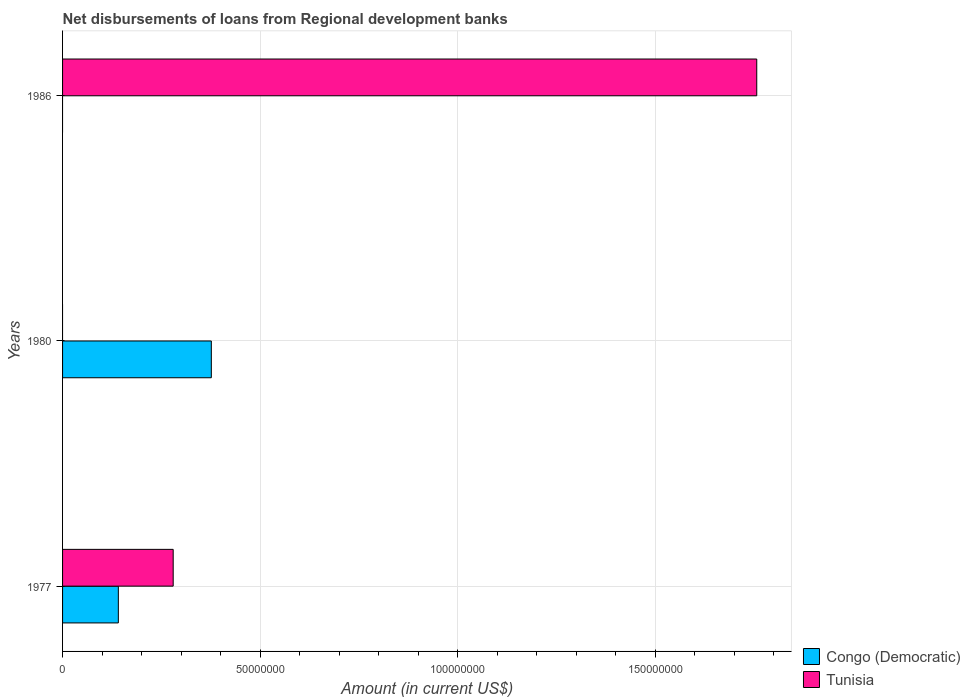How many different coloured bars are there?
Your response must be concise. 2. How many bars are there on the 2nd tick from the top?
Ensure brevity in your answer.  1. What is the label of the 3rd group of bars from the top?
Give a very brief answer. 1977. What is the amount of disbursements of loans from regional development banks in Tunisia in 1977?
Offer a terse response. 2.80e+07. Across all years, what is the maximum amount of disbursements of loans from regional development banks in Congo (Democratic)?
Offer a very short reply. 3.77e+07. In which year was the amount of disbursements of loans from regional development banks in Tunisia maximum?
Keep it short and to the point. 1986. What is the total amount of disbursements of loans from regional development banks in Congo (Democratic) in the graph?
Provide a succinct answer. 5.18e+07. What is the difference between the amount of disbursements of loans from regional development banks in Congo (Democratic) in 1977 and that in 1980?
Provide a succinct answer. -2.35e+07. What is the difference between the amount of disbursements of loans from regional development banks in Tunisia in 1977 and the amount of disbursements of loans from regional development banks in Congo (Democratic) in 1986?
Give a very brief answer. 2.80e+07. What is the average amount of disbursements of loans from regional development banks in Congo (Democratic) per year?
Provide a short and direct response. 1.73e+07. In the year 1977, what is the difference between the amount of disbursements of loans from regional development banks in Congo (Democratic) and amount of disbursements of loans from regional development banks in Tunisia?
Give a very brief answer. -1.39e+07. What is the ratio of the amount of disbursements of loans from regional development banks in Congo (Democratic) in 1977 to that in 1980?
Your response must be concise. 0.37. What is the difference between the highest and the lowest amount of disbursements of loans from regional development banks in Congo (Democratic)?
Keep it short and to the point. 3.77e+07. Is the sum of the amount of disbursements of loans from regional development banks in Congo (Democratic) in 1977 and 1980 greater than the maximum amount of disbursements of loans from regional development banks in Tunisia across all years?
Offer a very short reply. No. How many years are there in the graph?
Make the answer very short. 3. What is the difference between two consecutive major ticks on the X-axis?
Your answer should be compact. 5.00e+07. Does the graph contain any zero values?
Your answer should be compact. Yes. Does the graph contain grids?
Ensure brevity in your answer.  Yes. Where does the legend appear in the graph?
Ensure brevity in your answer.  Bottom right. How many legend labels are there?
Your response must be concise. 2. How are the legend labels stacked?
Your answer should be very brief. Vertical. What is the title of the graph?
Your answer should be very brief. Net disbursements of loans from Regional development banks. Does "Israel" appear as one of the legend labels in the graph?
Give a very brief answer. No. What is the label or title of the Y-axis?
Your answer should be very brief. Years. What is the Amount (in current US$) in Congo (Democratic) in 1977?
Offer a very short reply. 1.41e+07. What is the Amount (in current US$) in Tunisia in 1977?
Your answer should be very brief. 2.80e+07. What is the Amount (in current US$) in Congo (Democratic) in 1980?
Make the answer very short. 3.77e+07. What is the Amount (in current US$) in Congo (Democratic) in 1986?
Offer a terse response. 0. What is the Amount (in current US$) of Tunisia in 1986?
Give a very brief answer. 1.76e+08. Across all years, what is the maximum Amount (in current US$) of Congo (Democratic)?
Ensure brevity in your answer.  3.77e+07. Across all years, what is the maximum Amount (in current US$) in Tunisia?
Give a very brief answer. 1.76e+08. Across all years, what is the minimum Amount (in current US$) of Congo (Democratic)?
Give a very brief answer. 0. Across all years, what is the minimum Amount (in current US$) of Tunisia?
Your answer should be compact. 0. What is the total Amount (in current US$) of Congo (Democratic) in the graph?
Your response must be concise. 5.18e+07. What is the total Amount (in current US$) of Tunisia in the graph?
Your answer should be very brief. 2.04e+08. What is the difference between the Amount (in current US$) of Congo (Democratic) in 1977 and that in 1980?
Your answer should be very brief. -2.35e+07. What is the difference between the Amount (in current US$) of Tunisia in 1977 and that in 1986?
Provide a succinct answer. -1.48e+08. What is the difference between the Amount (in current US$) in Congo (Democratic) in 1977 and the Amount (in current US$) in Tunisia in 1986?
Your answer should be compact. -1.62e+08. What is the difference between the Amount (in current US$) of Congo (Democratic) in 1980 and the Amount (in current US$) of Tunisia in 1986?
Provide a short and direct response. -1.38e+08. What is the average Amount (in current US$) in Congo (Democratic) per year?
Ensure brevity in your answer.  1.73e+07. What is the average Amount (in current US$) in Tunisia per year?
Your answer should be compact. 6.79e+07. In the year 1977, what is the difference between the Amount (in current US$) of Congo (Democratic) and Amount (in current US$) of Tunisia?
Your response must be concise. -1.39e+07. What is the ratio of the Amount (in current US$) in Congo (Democratic) in 1977 to that in 1980?
Your answer should be compact. 0.37. What is the ratio of the Amount (in current US$) in Tunisia in 1977 to that in 1986?
Offer a terse response. 0.16. What is the difference between the highest and the lowest Amount (in current US$) in Congo (Democratic)?
Offer a terse response. 3.77e+07. What is the difference between the highest and the lowest Amount (in current US$) in Tunisia?
Provide a short and direct response. 1.76e+08. 